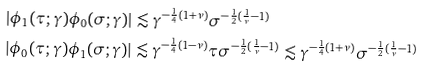<formula> <loc_0><loc_0><loc_500><loc_500>| \phi _ { 1 } ( \tau ; \gamma ) \phi _ { 0 } ( \sigma ; \gamma ) | & \lesssim \gamma ^ { - \frac { 1 } { 4 } ( 1 + \nu ) } \sigma ^ { - \frac { 1 } { 2 } ( \frac { 1 } { \nu } - 1 ) } \\ | \phi _ { 0 } ( \tau ; \gamma ) \phi _ { 1 } ( \sigma ; \gamma ) | & \lesssim \gamma ^ { - \frac { 1 } { 4 } ( 1 - \nu ) } \tau \sigma ^ { - \frac { 1 } { 2 } ( \frac { 1 } { \nu } - 1 ) } \lesssim \gamma ^ { - \frac { 1 } { 4 } ( 1 + \nu ) } \sigma ^ { - \frac { 1 } { 2 } ( \frac { 1 } { \nu } - 1 ) }</formula> 